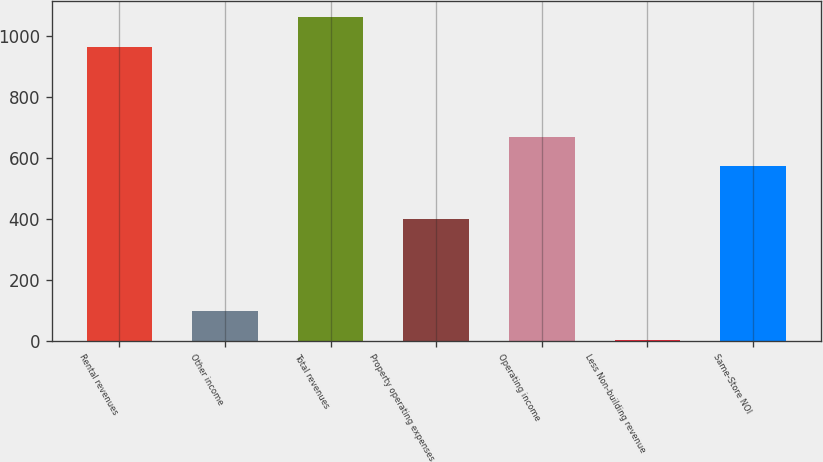Convert chart to OTSL. <chart><loc_0><loc_0><loc_500><loc_500><bar_chart><fcel>Rental revenues<fcel>Other income<fcel>Total revenues<fcel>Property operating expenses<fcel>Operating income<fcel>Less Non-building revenue<fcel>Same-Store NOI<nl><fcel>964.3<fcel>98.82<fcel>1061.42<fcel>398.7<fcel>669.62<fcel>1.7<fcel>572.5<nl></chart> 